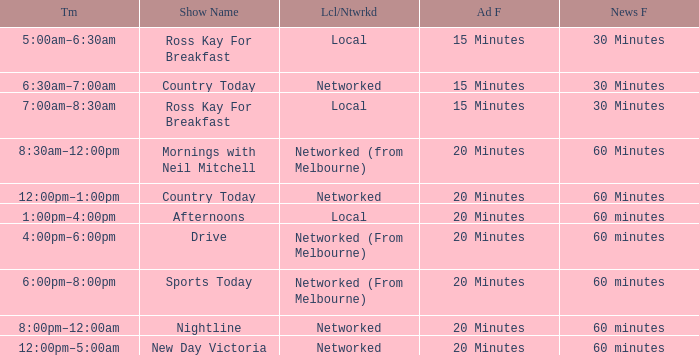What Local/Networked has a Show Name of nightline? Networked. 